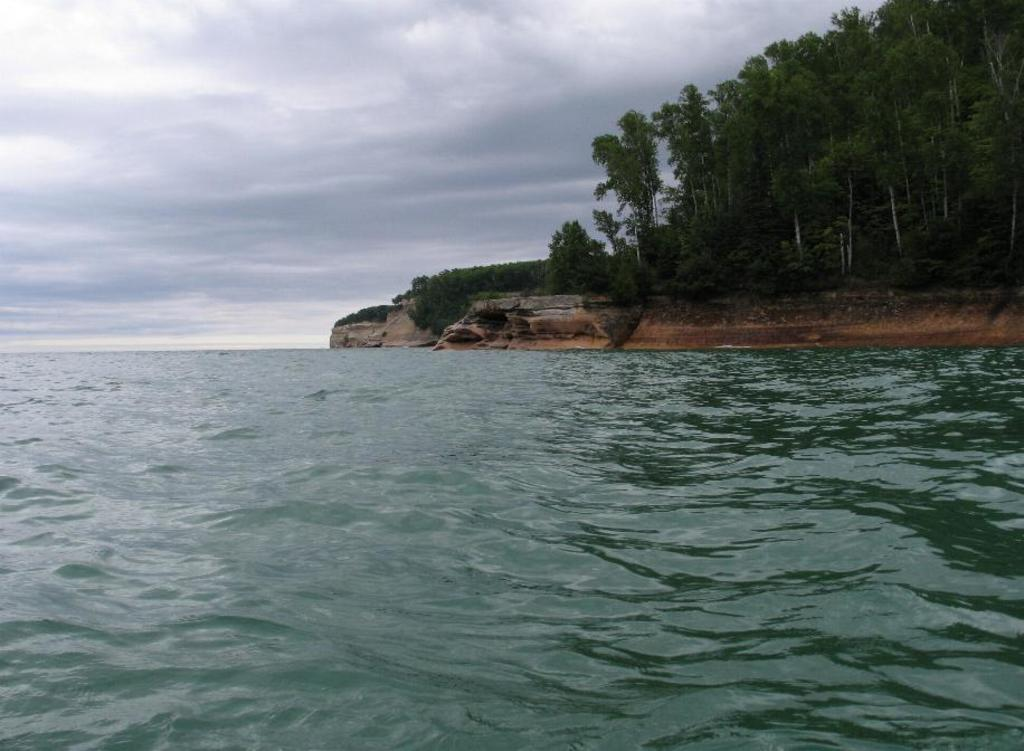What is visible in the image? Water is visible in the image. What can be seen in the background of the image? There are mountains, trees, and the sky visible in the background of the image. What type of jam is being spread on the trees in the image? There is no jam or spreading activity present in the image; it features water, mountains, trees, and the sky. 